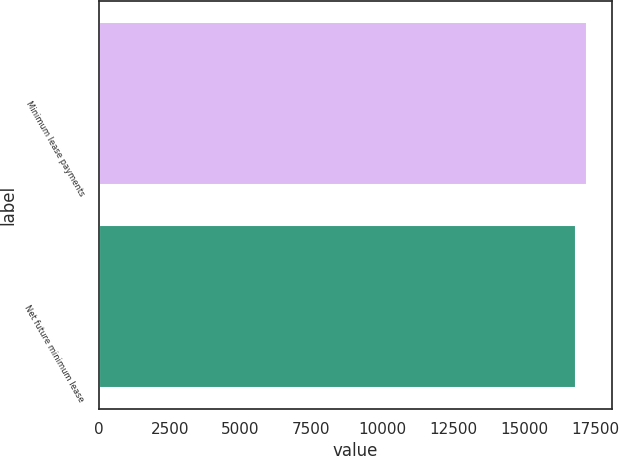<chart> <loc_0><loc_0><loc_500><loc_500><bar_chart><fcel>Minimum lease payments<fcel>Net future minimum lease<nl><fcel>17219<fcel>16812<nl></chart> 